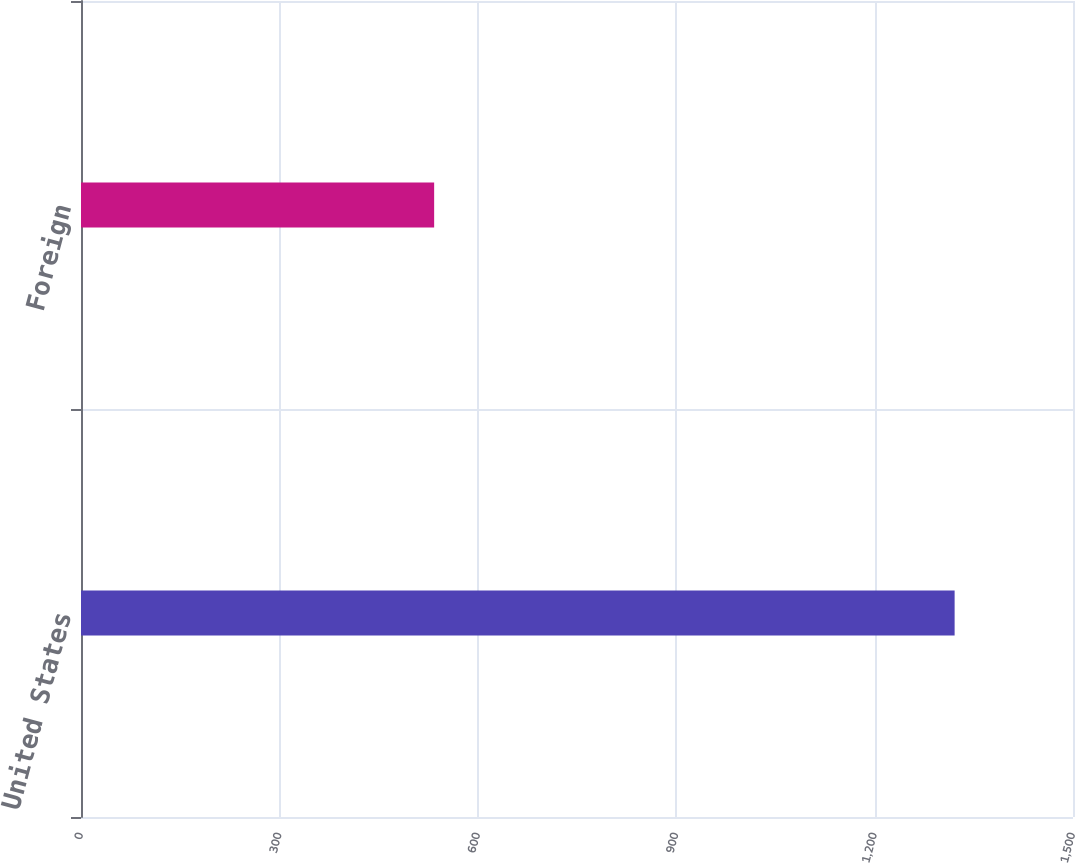<chart> <loc_0><loc_0><loc_500><loc_500><bar_chart><fcel>United States<fcel>Foreign<nl><fcel>1321<fcel>534<nl></chart> 